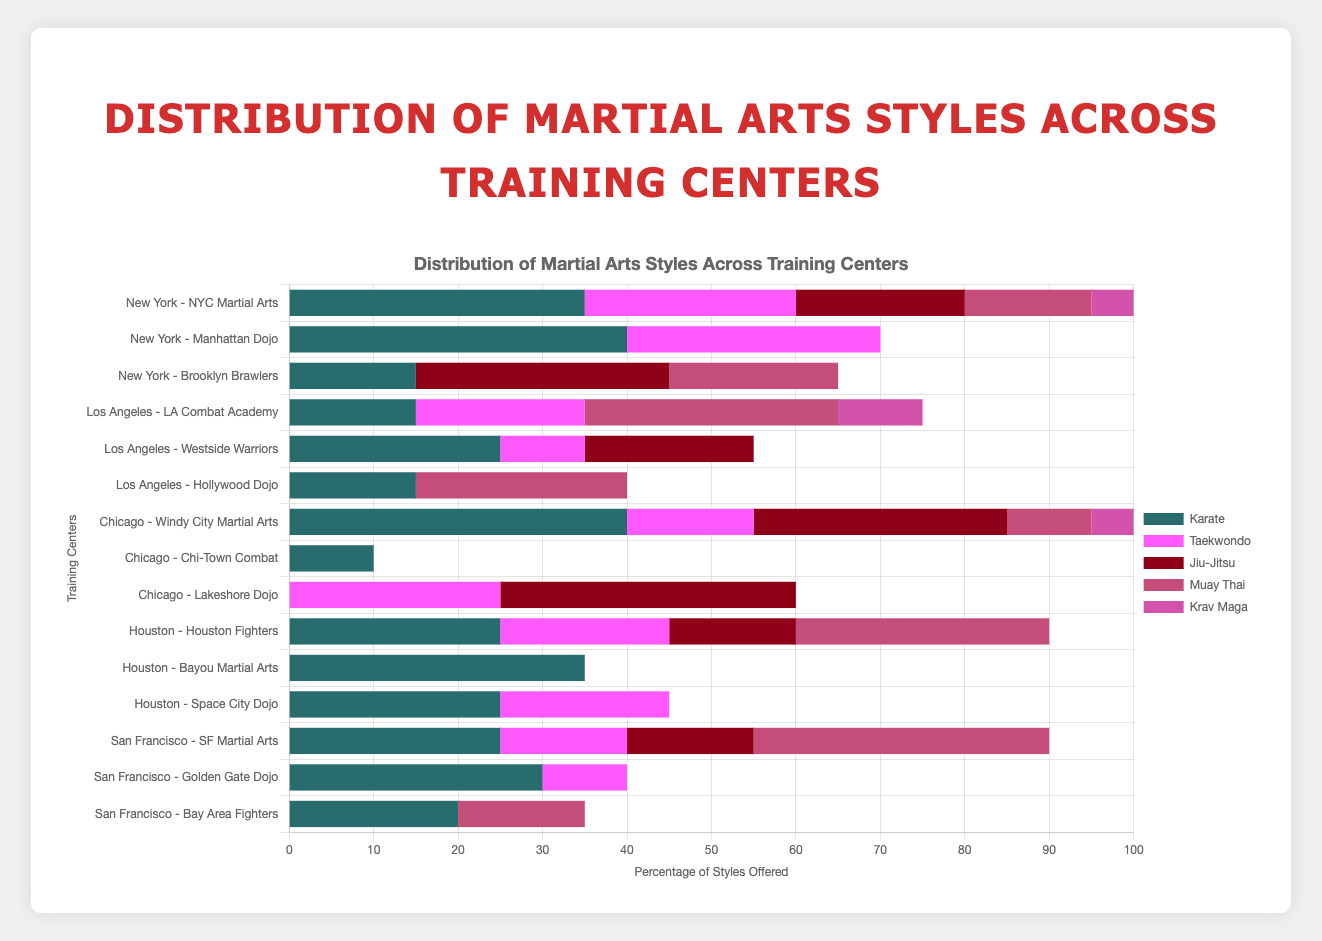What style is most frequently offered at training centers in New York? In the figure, look at the horizontal bars for training centers in New York and identify the style with the largest total length across all bars.
Answer: Karate Which city has the highest number of training centers offering Kickboxing? Observe the bars corresponding to each city's training centers and count how many segments pertain to Kickboxing. Compare the counts for each city.
Answer: San Francisco In Los Angeles, which training center offers the highest percentage of Muay Thai training? Within the Los Angeles section, compare the lengths of the Muay Thai segments for each training center and identify the one with the longest bar segment.
Answer: LA Combat Academy How does the distribution of Taekwondo offerings in Chicago compare between Windy City Martial Arts and Lakeshore Dojo? Find and compare the lengths of Taekwondo segments for Windy City Martial Arts and Lakeshore Dojo.
Answer: Windy City Martial Arts offers less Taekwondo compared to Lakeshore Dojo What is the total percentage of Brazilian Jiu-Jitsu styles offered across all training centers in Houston? Sum the lengths of the Brazilian Jiu-Jitsu segments for each training center in Houston.
Answer: 45% Which martial arts style has the smallest representation in San Francisco? Evaluate the total lengths of each martial arts style’s segments across all training centers in San Francisco and identify the shortest one.
Answer: Aikido Compare the total percentage of Krav Maga offered between New York and Los Angeles. Which city offers more? Add up the lengths of Krav Maga segments for all training centers in each city and compare.
Answer: Los Angeles Which training center in Houston offers the highest variety of martial arts styles? Check the number of different colored segments in each training center’s bar in Houston and identify the one with the most segments.
Answer: Space City Dojo What is the average percentage of Karate offerings across all training centers in San Francisco? Sum the lengths of Karate segments in each training center in San Francisco, then divide by the number of training centers.
Answer: Average is 25% Which training center in Chicago has the largest percentage dedicated to Judo? In the Chicago section, look at the lengths of Judo segments and identify the longest one.
Answer: Lakeshore Dojo 